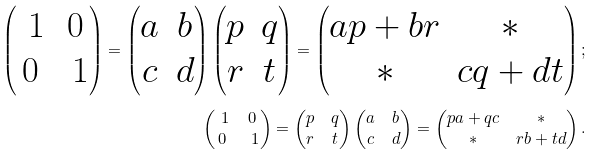Convert formula to latex. <formula><loc_0><loc_0><loc_500><loc_500>\begin{pmatrix} \ 1 & 0 \\ 0 & \ 1 \end{pmatrix} = \begin{pmatrix} a & b \\ c & d \end{pmatrix} \begin{pmatrix} p & q \\ r & t \end{pmatrix} = \begin{pmatrix} a p + b r & * \\ * & c q + d t \end{pmatrix} ; \\ \begin{pmatrix} \ 1 & 0 \\ 0 & \ 1 \end{pmatrix} = \begin{pmatrix} p & q \\ r & t \end{pmatrix} \begin{pmatrix} a & b \\ c & d \end{pmatrix} = \begin{pmatrix} p a + q c & * \\ * & r b + t d \end{pmatrix} .</formula> 